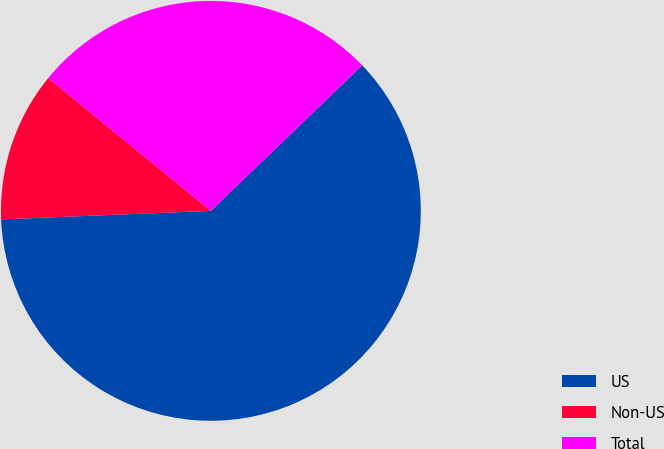Convert chart to OTSL. <chart><loc_0><loc_0><loc_500><loc_500><pie_chart><fcel>US<fcel>Non-US<fcel>Total<nl><fcel>61.54%<fcel>11.54%<fcel>26.92%<nl></chart> 